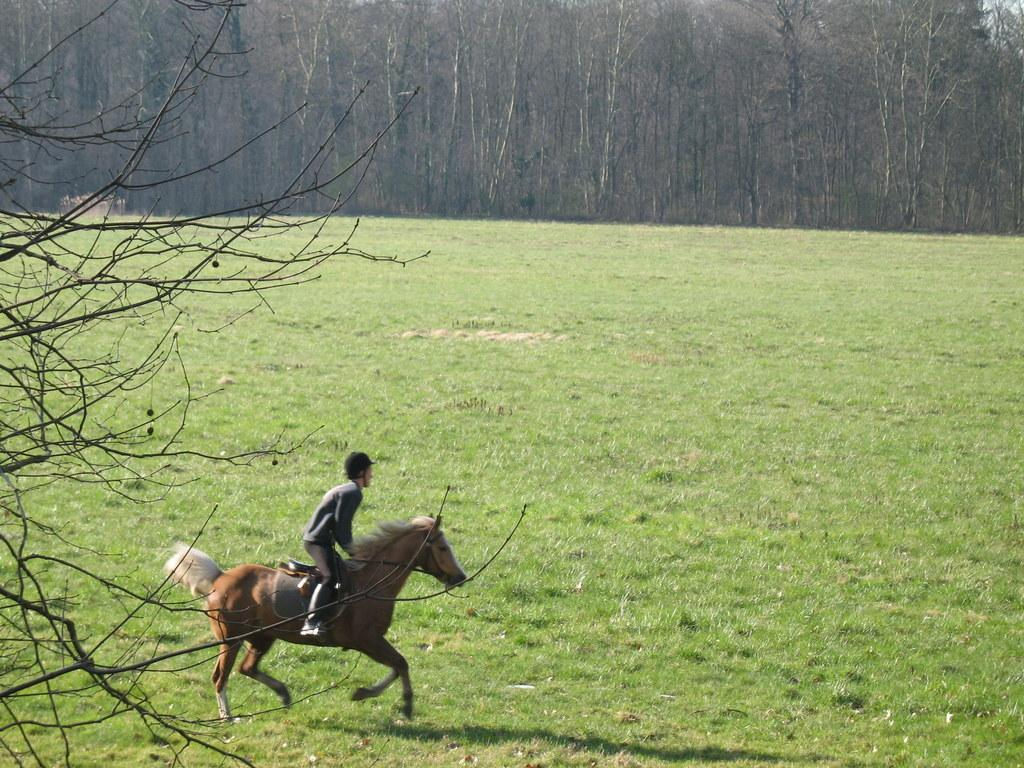What is the main subject of the image? The main subject of the image is a person riding a horse. What type of natural environment is visible in the image? There are trees and grass on the ground visible in the image. What type of manager is overseeing the waves in the image? There is no manager or waves present in the image; it features a person riding a horse in a natural environment. 